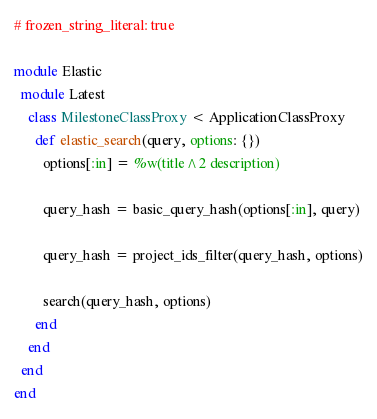Convert code to text. <code><loc_0><loc_0><loc_500><loc_500><_Ruby_># frozen_string_literal: true

module Elastic
  module Latest
    class MilestoneClassProxy < ApplicationClassProxy
      def elastic_search(query, options: {})
        options[:in] = %w(title^2 description)

        query_hash = basic_query_hash(options[:in], query)

        query_hash = project_ids_filter(query_hash, options)

        search(query_hash, options)
      end
    end
  end
end
</code> 